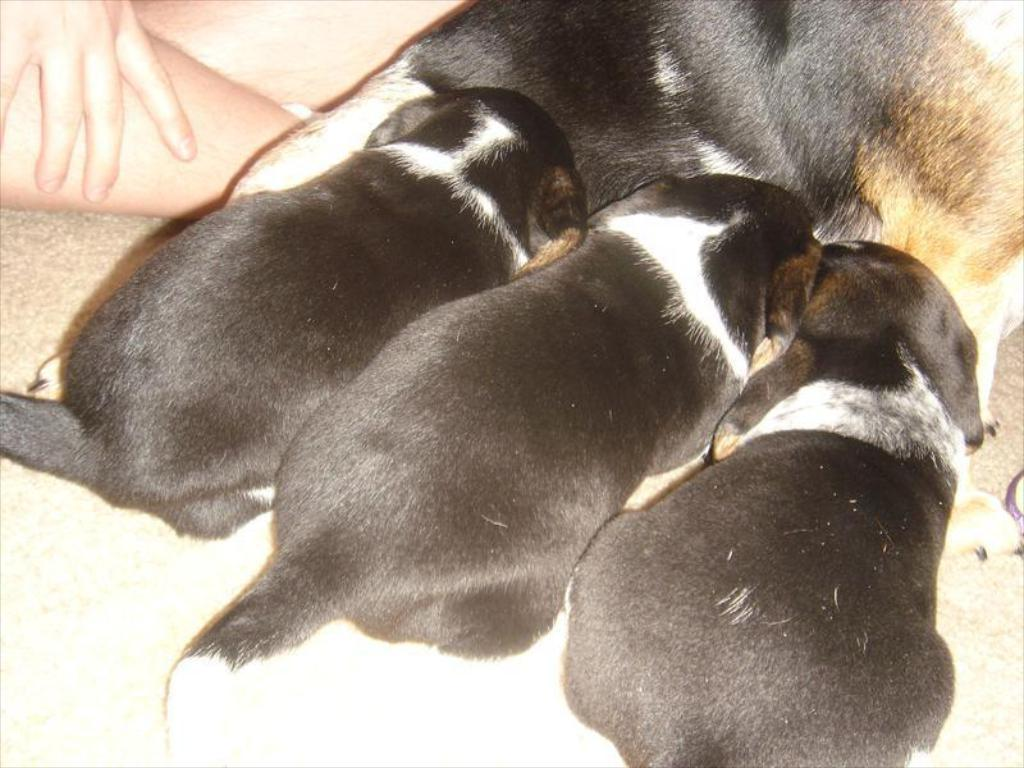How many dogs are present in the image? There are three dogs sitting in the image. What is the mother dog doing in the image? The mother dog is feeding the three dogs. Is there a person involved in the scene? Yes, there is a person holding the dogs. What type of fowl can be seen in the image? There are no fowl present in the image; it features three dogs and a person. 